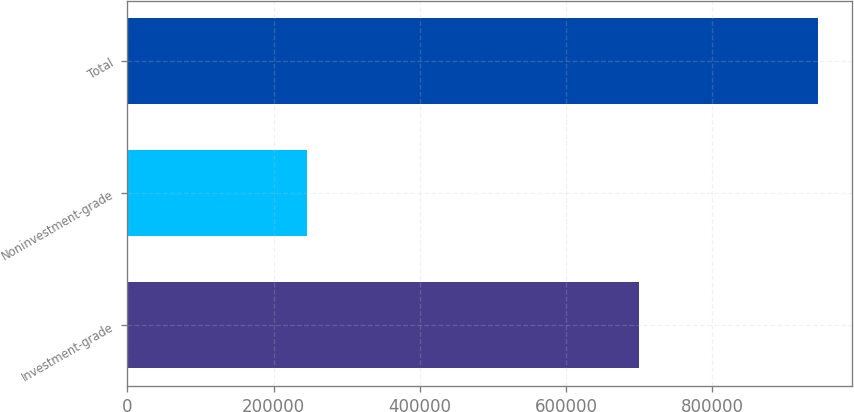<chart> <loc_0><loc_0><loc_500><loc_500><bar_chart><fcel>Investment-grade<fcel>Noninvestment-grade<fcel>Total<nl><fcel>699227<fcel>245151<fcel>944378<nl></chart> 